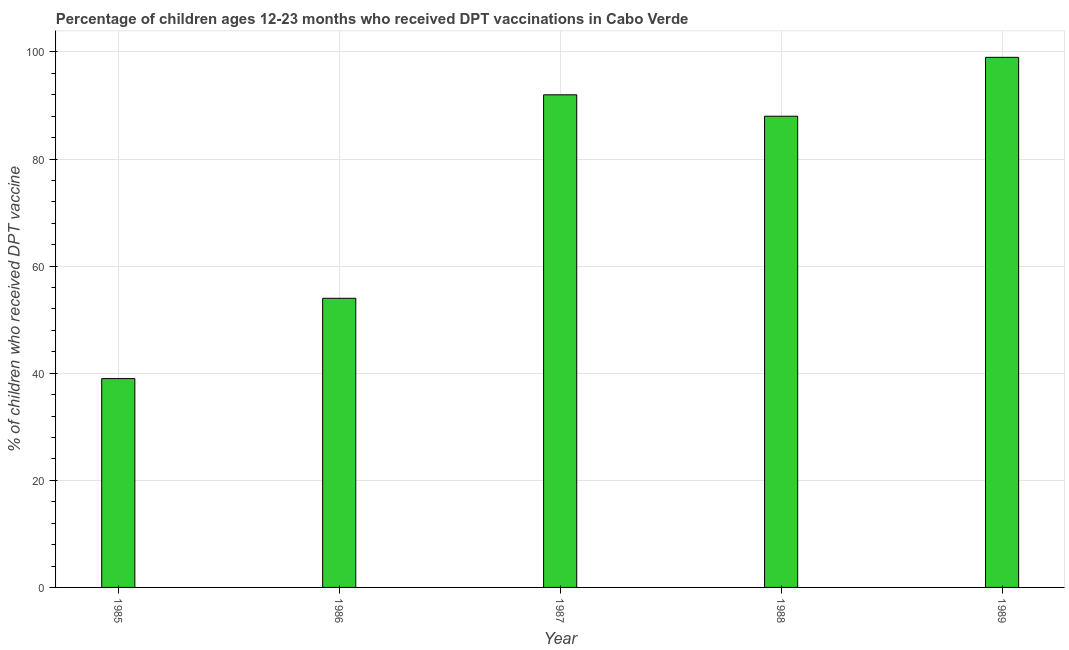Does the graph contain any zero values?
Keep it short and to the point. No. Does the graph contain grids?
Keep it short and to the point. Yes. What is the title of the graph?
Make the answer very short. Percentage of children ages 12-23 months who received DPT vaccinations in Cabo Verde. What is the label or title of the Y-axis?
Keep it short and to the point. % of children who received DPT vaccine. What is the percentage of children who received dpt vaccine in 1988?
Keep it short and to the point. 88. Across all years, what is the minimum percentage of children who received dpt vaccine?
Offer a very short reply. 39. What is the sum of the percentage of children who received dpt vaccine?
Give a very brief answer. 372. What is the difference between the percentage of children who received dpt vaccine in 1987 and 1989?
Offer a very short reply. -7. What is the median percentage of children who received dpt vaccine?
Offer a very short reply. 88. In how many years, is the percentage of children who received dpt vaccine greater than 12 %?
Ensure brevity in your answer.  5. Do a majority of the years between 1986 and 1987 (inclusive) have percentage of children who received dpt vaccine greater than 96 %?
Your answer should be very brief. No. What is the ratio of the percentage of children who received dpt vaccine in 1987 to that in 1988?
Ensure brevity in your answer.  1.04. Is the percentage of children who received dpt vaccine in 1985 less than that in 1986?
Offer a terse response. Yes. Is the sum of the percentage of children who received dpt vaccine in 1987 and 1989 greater than the maximum percentage of children who received dpt vaccine across all years?
Provide a short and direct response. Yes. Are all the bars in the graph horizontal?
Give a very brief answer. No. How many years are there in the graph?
Make the answer very short. 5. What is the difference between two consecutive major ticks on the Y-axis?
Make the answer very short. 20. What is the % of children who received DPT vaccine in 1986?
Provide a short and direct response. 54. What is the % of children who received DPT vaccine of 1987?
Give a very brief answer. 92. What is the difference between the % of children who received DPT vaccine in 1985 and 1986?
Provide a short and direct response. -15. What is the difference between the % of children who received DPT vaccine in 1985 and 1987?
Provide a succinct answer. -53. What is the difference between the % of children who received DPT vaccine in 1985 and 1988?
Give a very brief answer. -49. What is the difference between the % of children who received DPT vaccine in 1985 and 1989?
Your answer should be compact. -60. What is the difference between the % of children who received DPT vaccine in 1986 and 1987?
Your answer should be very brief. -38. What is the difference between the % of children who received DPT vaccine in 1986 and 1988?
Your answer should be compact. -34. What is the difference between the % of children who received DPT vaccine in 1986 and 1989?
Make the answer very short. -45. What is the difference between the % of children who received DPT vaccine in 1987 and 1988?
Your answer should be very brief. 4. What is the ratio of the % of children who received DPT vaccine in 1985 to that in 1986?
Give a very brief answer. 0.72. What is the ratio of the % of children who received DPT vaccine in 1985 to that in 1987?
Make the answer very short. 0.42. What is the ratio of the % of children who received DPT vaccine in 1985 to that in 1988?
Provide a succinct answer. 0.44. What is the ratio of the % of children who received DPT vaccine in 1985 to that in 1989?
Ensure brevity in your answer.  0.39. What is the ratio of the % of children who received DPT vaccine in 1986 to that in 1987?
Provide a succinct answer. 0.59. What is the ratio of the % of children who received DPT vaccine in 1986 to that in 1988?
Make the answer very short. 0.61. What is the ratio of the % of children who received DPT vaccine in 1986 to that in 1989?
Your answer should be compact. 0.55. What is the ratio of the % of children who received DPT vaccine in 1987 to that in 1988?
Offer a very short reply. 1.04. What is the ratio of the % of children who received DPT vaccine in 1987 to that in 1989?
Your answer should be very brief. 0.93. What is the ratio of the % of children who received DPT vaccine in 1988 to that in 1989?
Your response must be concise. 0.89. 